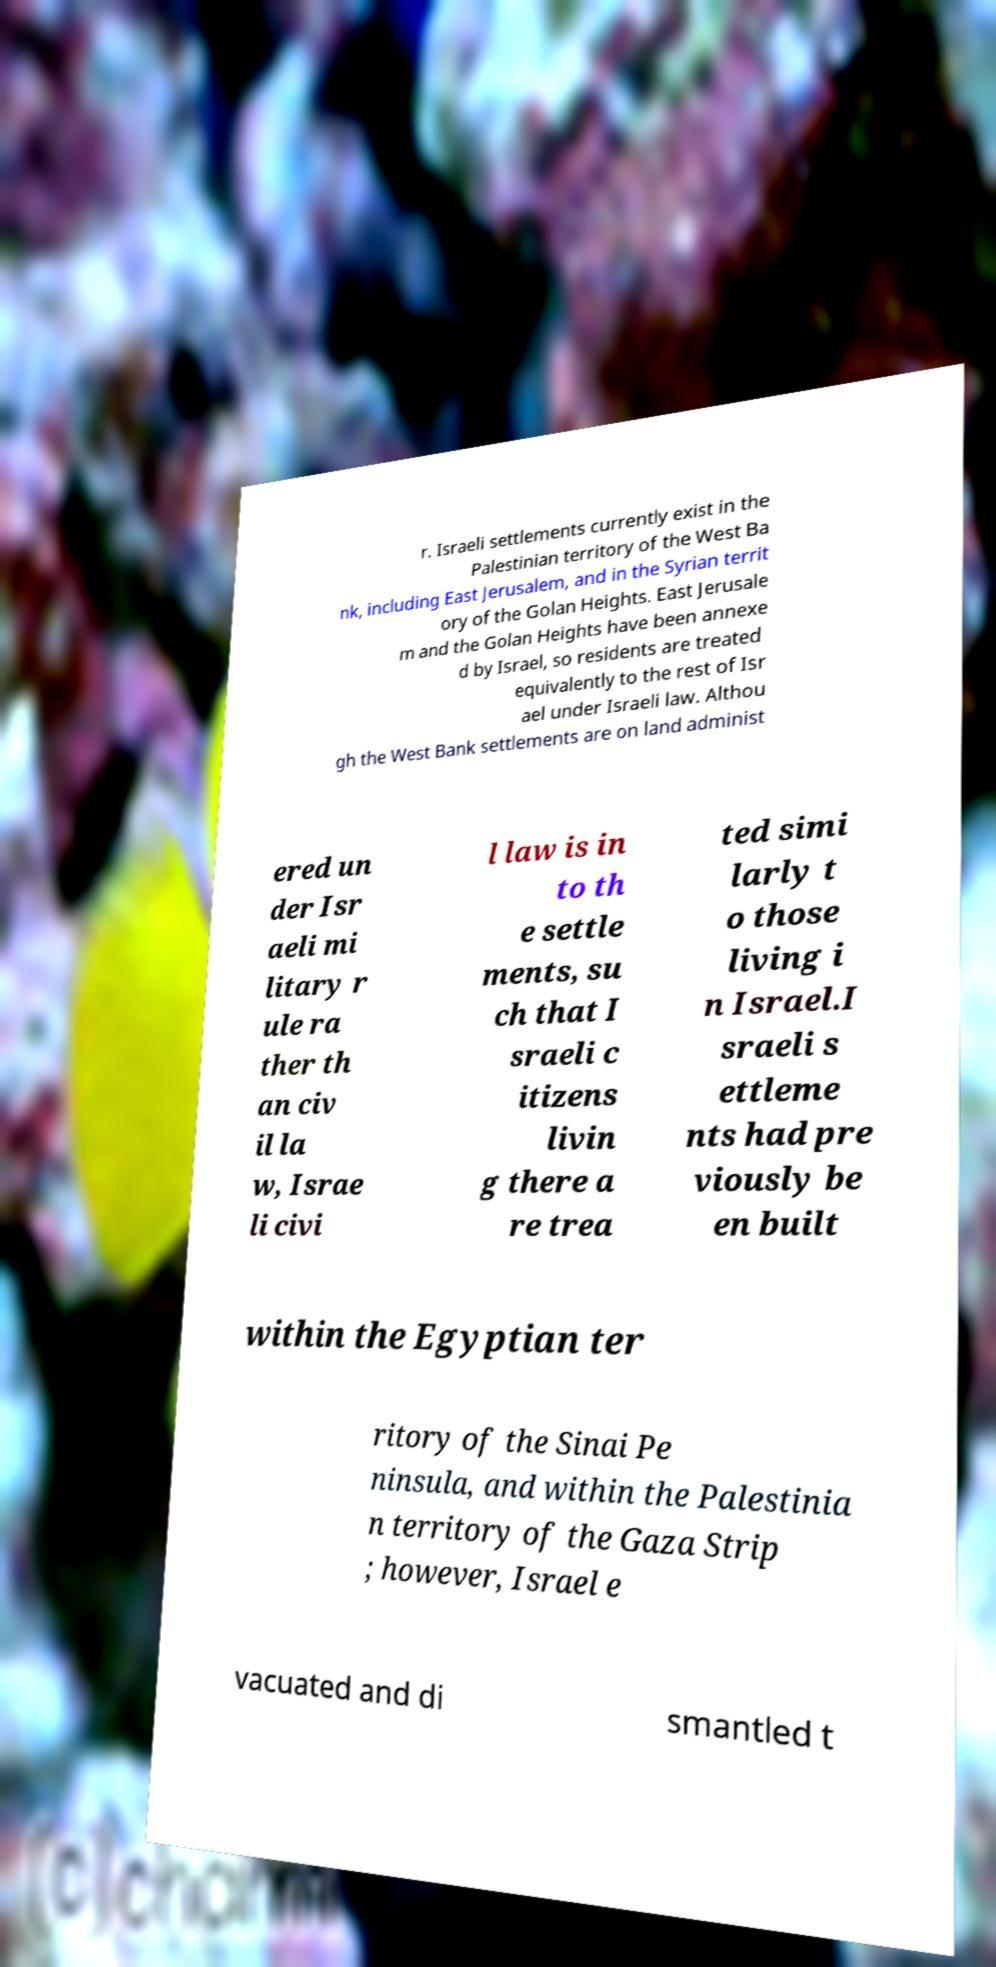I need the written content from this picture converted into text. Can you do that? r. Israeli settlements currently exist in the Palestinian territory of the West Ba nk, including East Jerusalem, and in the Syrian territ ory of the Golan Heights. East Jerusale m and the Golan Heights have been annexe d by Israel, so residents are treated equivalently to the rest of Isr ael under Israeli law. Althou gh the West Bank settlements are on land administ ered un der Isr aeli mi litary r ule ra ther th an civ il la w, Israe li civi l law is in to th e settle ments, su ch that I sraeli c itizens livin g there a re trea ted simi larly t o those living i n Israel.I sraeli s ettleme nts had pre viously be en built within the Egyptian ter ritory of the Sinai Pe ninsula, and within the Palestinia n territory of the Gaza Strip ; however, Israel e vacuated and di smantled t 